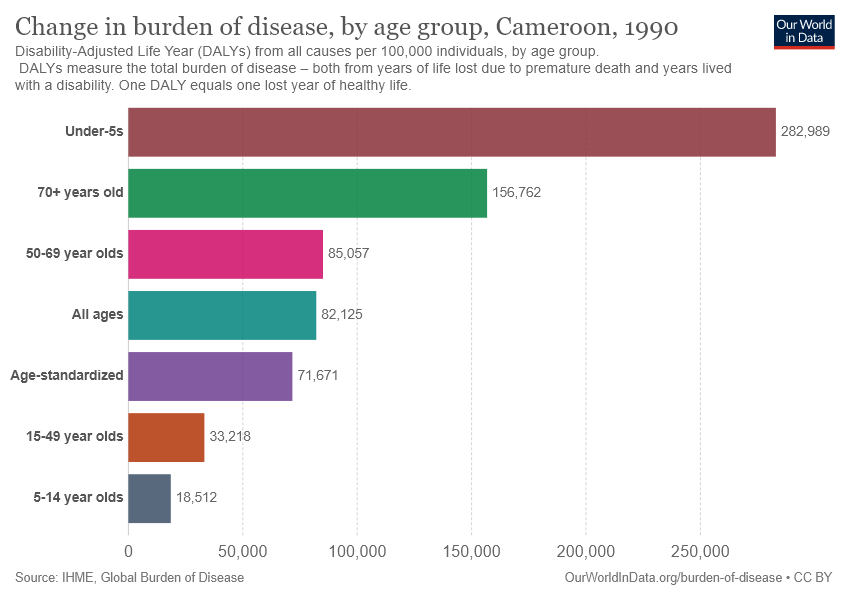List a handful of essential elements in this visual. There are 7 age groups mentioned in the graph. The value of the age group 50-69 is greater than the value of all ages. 